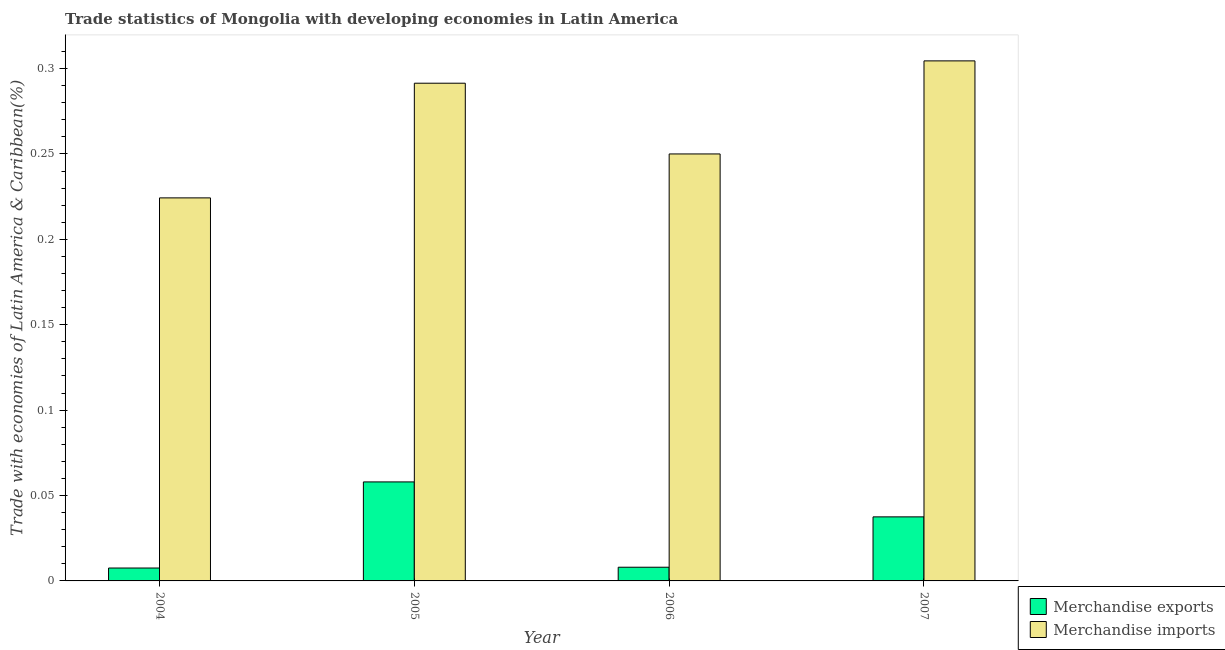How many bars are there on the 3rd tick from the left?
Your answer should be very brief. 2. How many bars are there on the 3rd tick from the right?
Give a very brief answer. 2. What is the merchandise exports in 2006?
Make the answer very short. 0.01. Across all years, what is the maximum merchandise imports?
Your response must be concise. 0.3. Across all years, what is the minimum merchandise exports?
Provide a succinct answer. 0.01. In which year was the merchandise imports maximum?
Make the answer very short. 2007. What is the total merchandise exports in the graph?
Offer a very short reply. 0.11. What is the difference between the merchandise exports in 2004 and that in 2007?
Make the answer very short. -0.03. What is the difference between the merchandise exports in 2006 and the merchandise imports in 2007?
Your answer should be compact. -0.03. What is the average merchandise imports per year?
Your response must be concise. 0.27. In how many years, is the merchandise exports greater than 0.16000000000000003 %?
Make the answer very short. 0. What is the ratio of the merchandise imports in 2004 to that in 2007?
Keep it short and to the point. 0.74. Is the merchandise imports in 2006 less than that in 2007?
Make the answer very short. Yes. Is the difference between the merchandise exports in 2004 and 2006 greater than the difference between the merchandise imports in 2004 and 2006?
Your answer should be very brief. No. What is the difference between the highest and the second highest merchandise imports?
Your answer should be compact. 0.01. What is the difference between the highest and the lowest merchandise exports?
Offer a very short reply. 0.05. Is the sum of the merchandise exports in 2004 and 2007 greater than the maximum merchandise imports across all years?
Your response must be concise. No. How many bars are there?
Your answer should be compact. 8. Are all the bars in the graph horizontal?
Offer a terse response. No. How many legend labels are there?
Offer a terse response. 2. How are the legend labels stacked?
Your answer should be very brief. Vertical. What is the title of the graph?
Make the answer very short. Trade statistics of Mongolia with developing economies in Latin America. What is the label or title of the X-axis?
Give a very brief answer. Year. What is the label or title of the Y-axis?
Your answer should be compact. Trade with economies of Latin America & Caribbean(%). What is the Trade with economies of Latin America & Caribbean(%) in Merchandise exports in 2004?
Offer a very short reply. 0.01. What is the Trade with economies of Latin America & Caribbean(%) in Merchandise imports in 2004?
Your answer should be very brief. 0.22. What is the Trade with economies of Latin America & Caribbean(%) in Merchandise exports in 2005?
Your answer should be very brief. 0.06. What is the Trade with economies of Latin America & Caribbean(%) in Merchandise imports in 2005?
Give a very brief answer. 0.29. What is the Trade with economies of Latin America & Caribbean(%) in Merchandise exports in 2006?
Provide a succinct answer. 0.01. What is the Trade with economies of Latin America & Caribbean(%) of Merchandise imports in 2006?
Offer a very short reply. 0.25. What is the Trade with economies of Latin America & Caribbean(%) in Merchandise exports in 2007?
Ensure brevity in your answer.  0.04. What is the Trade with economies of Latin America & Caribbean(%) in Merchandise imports in 2007?
Provide a short and direct response. 0.3. Across all years, what is the maximum Trade with economies of Latin America & Caribbean(%) of Merchandise exports?
Offer a very short reply. 0.06. Across all years, what is the maximum Trade with economies of Latin America & Caribbean(%) of Merchandise imports?
Your answer should be compact. 0.3. Across all years, what is the minimum Trade with economies of Latin America & Caribbean(%) of Merchandise exports?
Give a very brief answer. 0.01. Across all years, what is the minimum Trade with economies of Latin America & Caribbean(%) in Merchandise imports?
Your answer should be very brief. 0.22. What is the total Trade with economies of Latin America & Caribbean(%) of Merchandise exports in the graph?
Give a very brief answer. 0.11. What is the total Trade with economies of Latin America & Caribbean(%) of Merchandise imports in the graph?
Your answer should be compact. 1.07. What is the difference between the Trade with economies of Latin America & Caribbean(%) of Merchandise exports in 2004 and that in 2005?
Provide a short and direct response. -0.05. What is the difference between the Trade with economies of Latin America & Caribbean(%) in Merchandise imports in 2004 and that in 2005?
Your answer should be compact. -0.07. What is the difference between the Trade with economies of Latin America & Caribbean(%) of Merchandise exports in 2004 and that in 2006?
Your answer should be compact. -0. What is the difference between the Trade with economies of Latin America & Caribbean(%) in Merchandise imports in 2004 and that in 2006?
Make the answer very short. -0.03. What is the difference between the Trade with economies of Latin America & Caribbean(%) of Merchandise exports in 2004 and that in 2007?
Keep it short and to the point. -0.03. What is the difference between the Trade with economies of Latin America & Caribbean(%) in Merchandise imports in 2004 and that in 2007?
Offer a terse response. -0.08. What is the difference between the Trade with economies of Latin America & Caribbean(%) of Merchandise exports in 2005 and that in 2006?
Make the answer very short. 0.05. What is the difference between the Trade with economies of Latin America & Caribbean(%) in Merchandise imports in 2005 and that in 2006?
Make the answer very short. 0.04. What is the difference between the Trade with economies of Latin America & Caribbean(%) in Merchandise exports in 2005 and that in 2007?
Your answer should be very brief. 0.02. What is the difference between the Trade with economies of Latin America & Caribbean(%) of Merchandise imports in 2005 and that in 2007?
Keep it short and to the point. -0.01. What is the difference between the Trade with economies of Latin America & Caribbean(%) of Merchandise exports in 2006 and that in 2007?
Your response must be concise. -0.03. What is the difference between the Trade with economies of Latin America & Caribbean(%) of Merchandise imports in 2006 and that in 2007?
Provide a succinct answer. -0.05. What is the difference between the Trade with economies of Latin America & Caribbean(%) in Merchandise exports in 2004 and the Trade with economies of Latin America & Caribbean(%) in Merchandise imports in 2005?
Provide a short and direct response. -0.28. What is the difference between the Trade with economies of Latin America & Caribbean(%) in Merchandise exports in 2004 and the Trade with economies of Latin America & Caribbean(%) in Merchandise imports in 2006?
Give a very brief answer. -0.24. What is the difference between the Trade with economies of Latin America & Caribbean(%) in Merchandise exports in 2004 and the Trade with economies of Latin America & Caribbean(%) in Merchandise imports in 2007?
Your answer should be very brief. -0.3. What is the difference between the Trade with economies of Latin America & Caribbean(%) in Merchandise exports in 2005 and the Trade with economies of Latin America & Caribbean(%) in Merchandise imports in 2006?
Provide a short and direct response. -0.19. What is the difference between the Trade with economies of Latin America & Caribbean(%) of Merchandise exports in 2005 and the Trade with economies of Latin America & Caribbean(%) of Merchandise imports in 2007?
Ensure brevity in your answer.  -0.25. What is the difference between the Trade with economies of Latin America & Caribbean(%) of Merchandise exports in 2006 and the Trade with economies of Latin America & Caribbean(%) of Merchandise imports in 2007?
Provide a succinct answer. -0.3. What is the average Trade with economies of Latin America & Caribbean(%) of Merchandise exports per year?
Your answer should be compact. 0.03. What is the average Trade with economies of Latin America & Caribbean(%) in Merchandise imports per year?
Your response must be concise. 0.27. In the year 2004, what is the difference between the Trade with economies of Latin America & Caribbean(%) of Merchandise exports and Trade with economies of Latin America & Caribbean(%) of Merchandise imports?
Keep it short and to the point. -0.22. In the year 2005, what is the difference between the Trade with economies of Latin America & Caribbean(%) in Merchandise exports and Trade with economies of Latin America & Caribbean(%) in Merchandise imports?
Your answer should be compact. -0.23. In the year 2006, what is the difference between the Trade with economies of Latin America & Caribbean(%) in Merchandise exports and Trade with economies of Latin America & Caribbean(%) in Merchandise imports?
Your answer should be very brief. -0.24. In the year 2007, what is the difference between the Trade with economies of Latin America & Caribbean(%) in Merchandise exports and Trade with economies of Latin America & Caribbean(%) in Merchandise imports?
Give a very brief answer. -0.27. What is the ratio of the Trade with economies of Latin America & Caribbean(%) of Merchandise exports in 2004 to that in 2005?
Keep it short and to the point. 0.13. What is the ratio of the Trade with economies of Latin America & Caribbean(%) in Merchandise imports in 2004 to that in 2005?
Offer a terse response. 0.77. What is the ratio of the Trade with economies of Latin America & Caribbean(%) of Merchandise exports in 2004 to that in 2006?
Offer a very short reply. 0.94. What is the ratio of the Trade with economies of Latin America & Caribbean(%) of Merchandise imports in 2004 to that in 2006?
Keep it short and to the point. 0.9. What is the ratio of the Trade with economies of Latin America & Caribbean(%) in Merchandise exports in 2004 to that in 2007?
Your answer should be compact. 0.2. What is the ratio of the Trade with economies of Latin America & Caribbean(%) of Merchandise imports in 2004 to that in 2007?
Offer a terse response. 0.74. What is the ratio of the Trade with economies of Latin America & Caribbean(%) in Merchandise exports in 2005 to that in 2006?
Your answer should be very brief. 7.23. What is the ratio of the Trade with economies of Latin America & Caribbean(%) in Merchandise imports in 2005 to that in 2006?
Keep it short and to the point. 1.17. What is the ratio of the Trade with economies of Latin America & Caribbean(%) in Merchandise exports in 2005 to that in 2007?
Offer a very short reply. 1.55. What is the ratio of the Trade with economies of Latin America & Caribbean(%) in Merchandise imports in 2005 to that in 2007?
Give a very brief answer. 0.96. What is the ratio of the Trade with economies of Latin America & Caribbean(%) in Merchandise exports in 2006 to that in 2007?
Provide a succinct answer. 0.21. What is the ratio of the Trade with economies of Latin America & Caribbean(%) of Merchandise imports in 2006 to that in 2007?
Your answer should be very brief. 0.82. What is the difference between the highest and the second highest Trade with economies of Latin America & Caribbean(%) of Merchandise exports?
Offer a terse response. 0.02. What is the difference between the highest and the second highest Trade with economies of Latin America & Caribbean(%) in Merchandise imports?
Your response must be concise. 0.01. What is the difference between the highest and the lowest Trade with economies of Latin America & Caribbean(%) in Merchandise exports?
Give a very brief answer. 0.05. What is the difference between the highest and the lowest Trade with economies of Latin America & Caribbean(%) in Merchandise imports?
Offer a terse response. 0.08. 